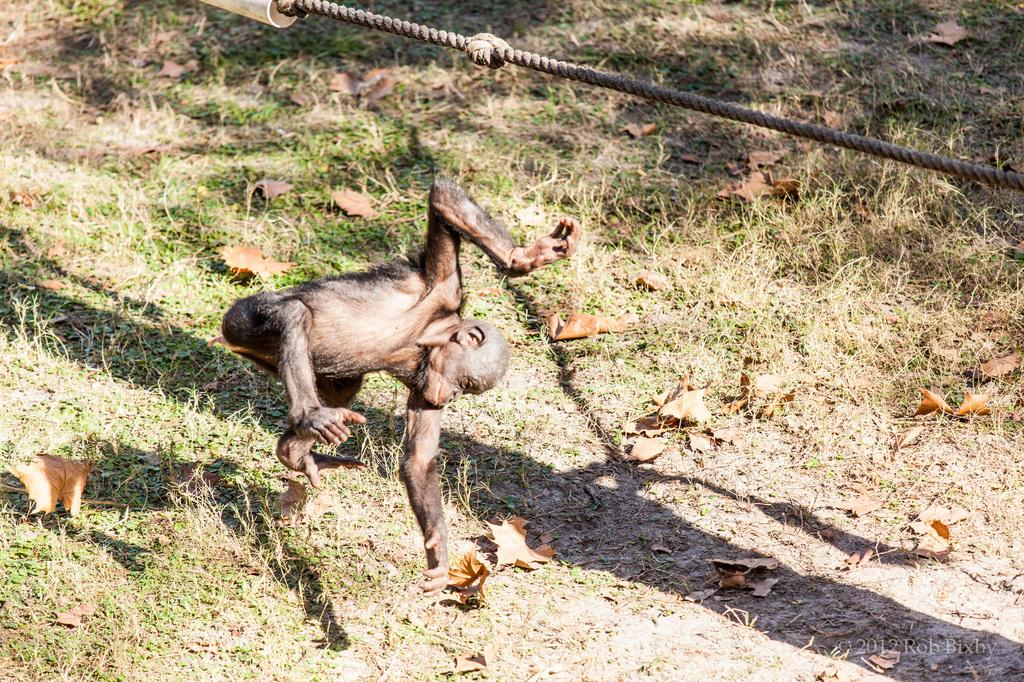What animal is in the foreground of the image? There is a chimpanzee in the foreground of the image. What is the chimpanzee doing in the image? The chimpanzee is in the air. What can be seen at the top of the image? There is a rope at the top of the image. What type of vegetation is present on the ground? Dry leaves are present on the grass. How many dimes are scattered on the grass in the image? There are no dimes present in the image; it features a chimpanzee in the air with a rope at the top and dry leaves on the grass. 